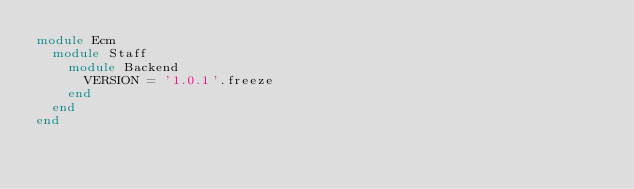Convert code to text. <code><loc_0><loc_0><loc_500><loc_500><_Ruby_>module Ecm
  module Staff
    module Backend
      VERSION = '1.0.1'.freeze
    end
  end
end
</code> 